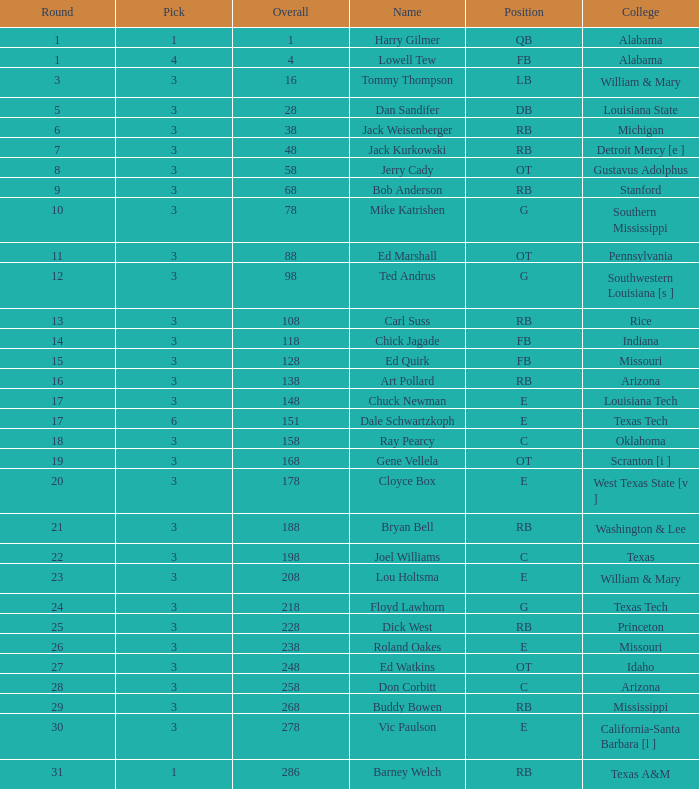What is stanford's average overall? 68.0. 